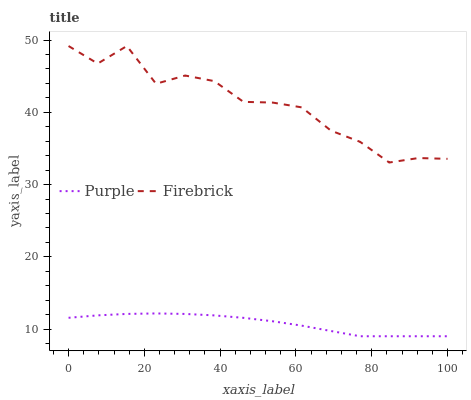Does Purple have the minimum area under the curve?
Answer yes or no. Yes. Does Firebrick have the maximum area under the curve?
Answer yes or no. Yes. Does Firebrick have the minimum area under the curve?
Answer yes or no. No. Is Purple the smoothest?
Answer yes or no. Yes. Is Firebrick the roughest?
Answer yes or no. Yes. Is Firebrick the smoothest?
Answer yes or no. No. Does Purple have the lowest value?
Answer yes or no. Yes. Does Firebrick have the lowest value?
Answer yes or no. No. Does Firebrick have the highest value?
Answer yes or no. Yes. Is Purple less than Firebrick?
Answer yes or no. Yes. Is Firebrick greater than Purple?
Answer yes or no. Yes. Does Purple intersect Firebrick?
Answer yes or no. No. 